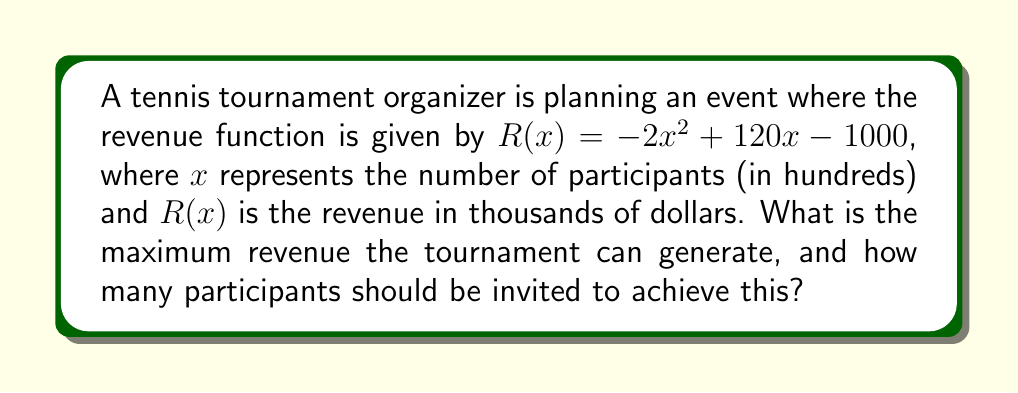Could you help me with this problem? To find the maximum revenue and the optimal number of participants, we need to follow these steps:

1) The maximum of a quadratic function occurs at the vertex of the parabola. For a function in the form $f(x) = ax^2 + bx + c$, the x-coordinate of the vertex is given by $x = -\frac{b}{2a}$.

2) In our revenue function $R(x) = -2x^2 + 120x - 1000$, we have:
   $a = -2$
   $b = 120$
   $c = -1000$

3) Calculating the x-coordinate of the vertex:
   $x = -\frac{b}{2a} = -\frac{120}{2(-2)} = -\frac{120}{-4} = 30$

4) This means the maximum revenue occurs when $x = 30$ hundred participants, or 3000 participants.

5) To find the maximum revenue, we substitute $x = 30$ into the revenue function:
   $R(30) = -2(30)^2 + 120(30) - 1000$
          $= -2(900) + 3600 - 1000$
          $= -1800 + 3600 - 1000$
          $= 800$

6) Since $R(x)$ is in thousands of dollars, the maximum revenue is $800,000.
Answer: $800,000 with 3000 participants 